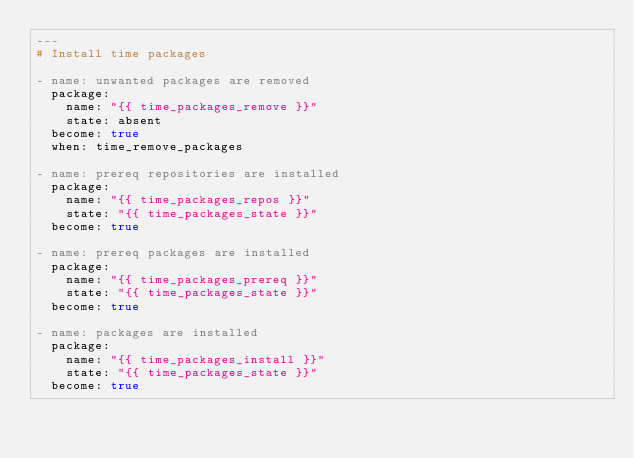<code> <loc_0><loc_0><loc_500><loc_500><_YAML_>---
# Install time packages

- name: unwanted packages are removed
  package:
    name: "{{ time_packages_remove }}"
    state: absent
  become: true
  when: time_remove_packages

- name: prereq repositories are installed
  package:
    name: "{{ time_packages_repos }}"
    state: "{{ time_packages_state }}"
  become: true

- name: prereq packages are installed
  package:
    name: "{{ time_packages_prereq }}"
    state: "{{ time_packages_state }}"
  become: true

- name: packages are installed
  package:
    name: "{{ time_packages_install }}"
    state: "{{ time_packages_state }}"
  become: true
</code> 